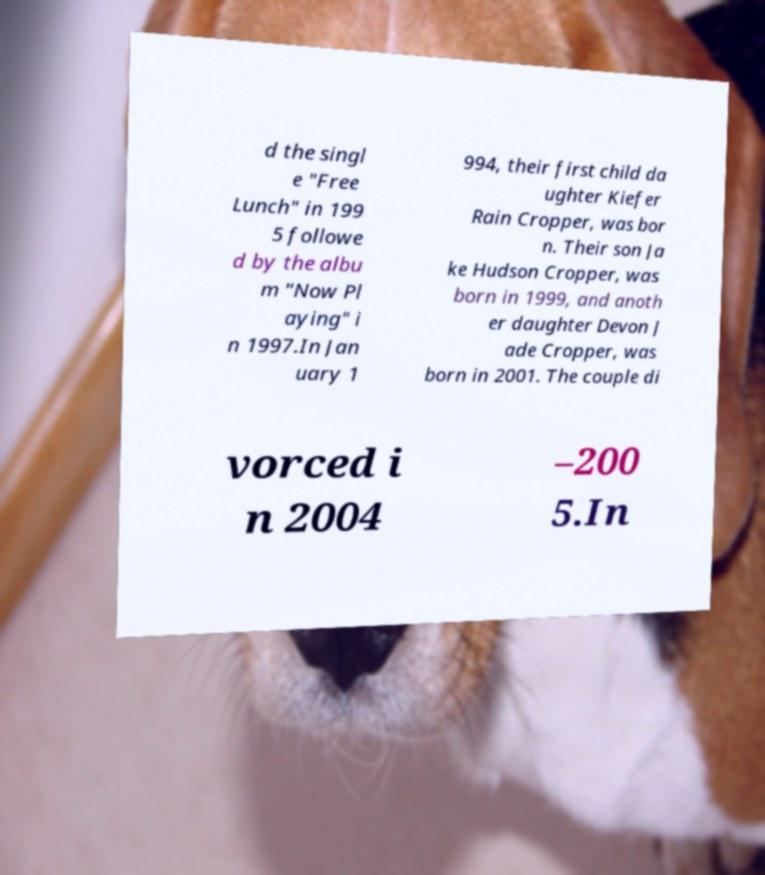There's text embedded in this image that I need extracted. Can you transcribe it verbatim? d the singl e "Free Lunch" in 199 5 followe d by the albu m "Now Pl aying" i n 1997.In Jan uary 1 994, their first child da ughter Kiefer Rain Cropper, was bor n. Their son Ja ke Hudson Cropper, was born in 1999, and anoth er daughter Devon J ade Cropper, was born in 2001. The couple di vorced i n 2004 –200 5.In 